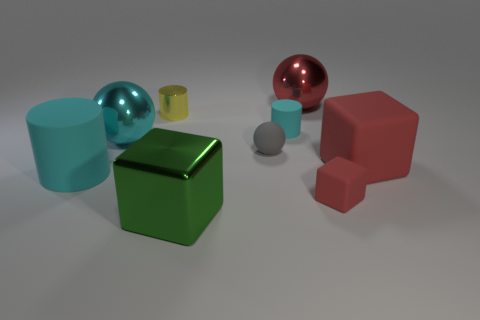Add 1 small blue matte cylinders. How many objects exist? 10 Subtract all balls. How many objects are left? 6 Add 7 yellow shiny cylinders. How many yellow shiny cylinders are left? 8 Add 7 small rubber cubes. How many small rubber cubes exist? 8 Subtract 2 cyan cylinders. How many objects are left? 7 Subtract all small rubber cylinders. Subtract all small blocks. How many objects are left? 7 